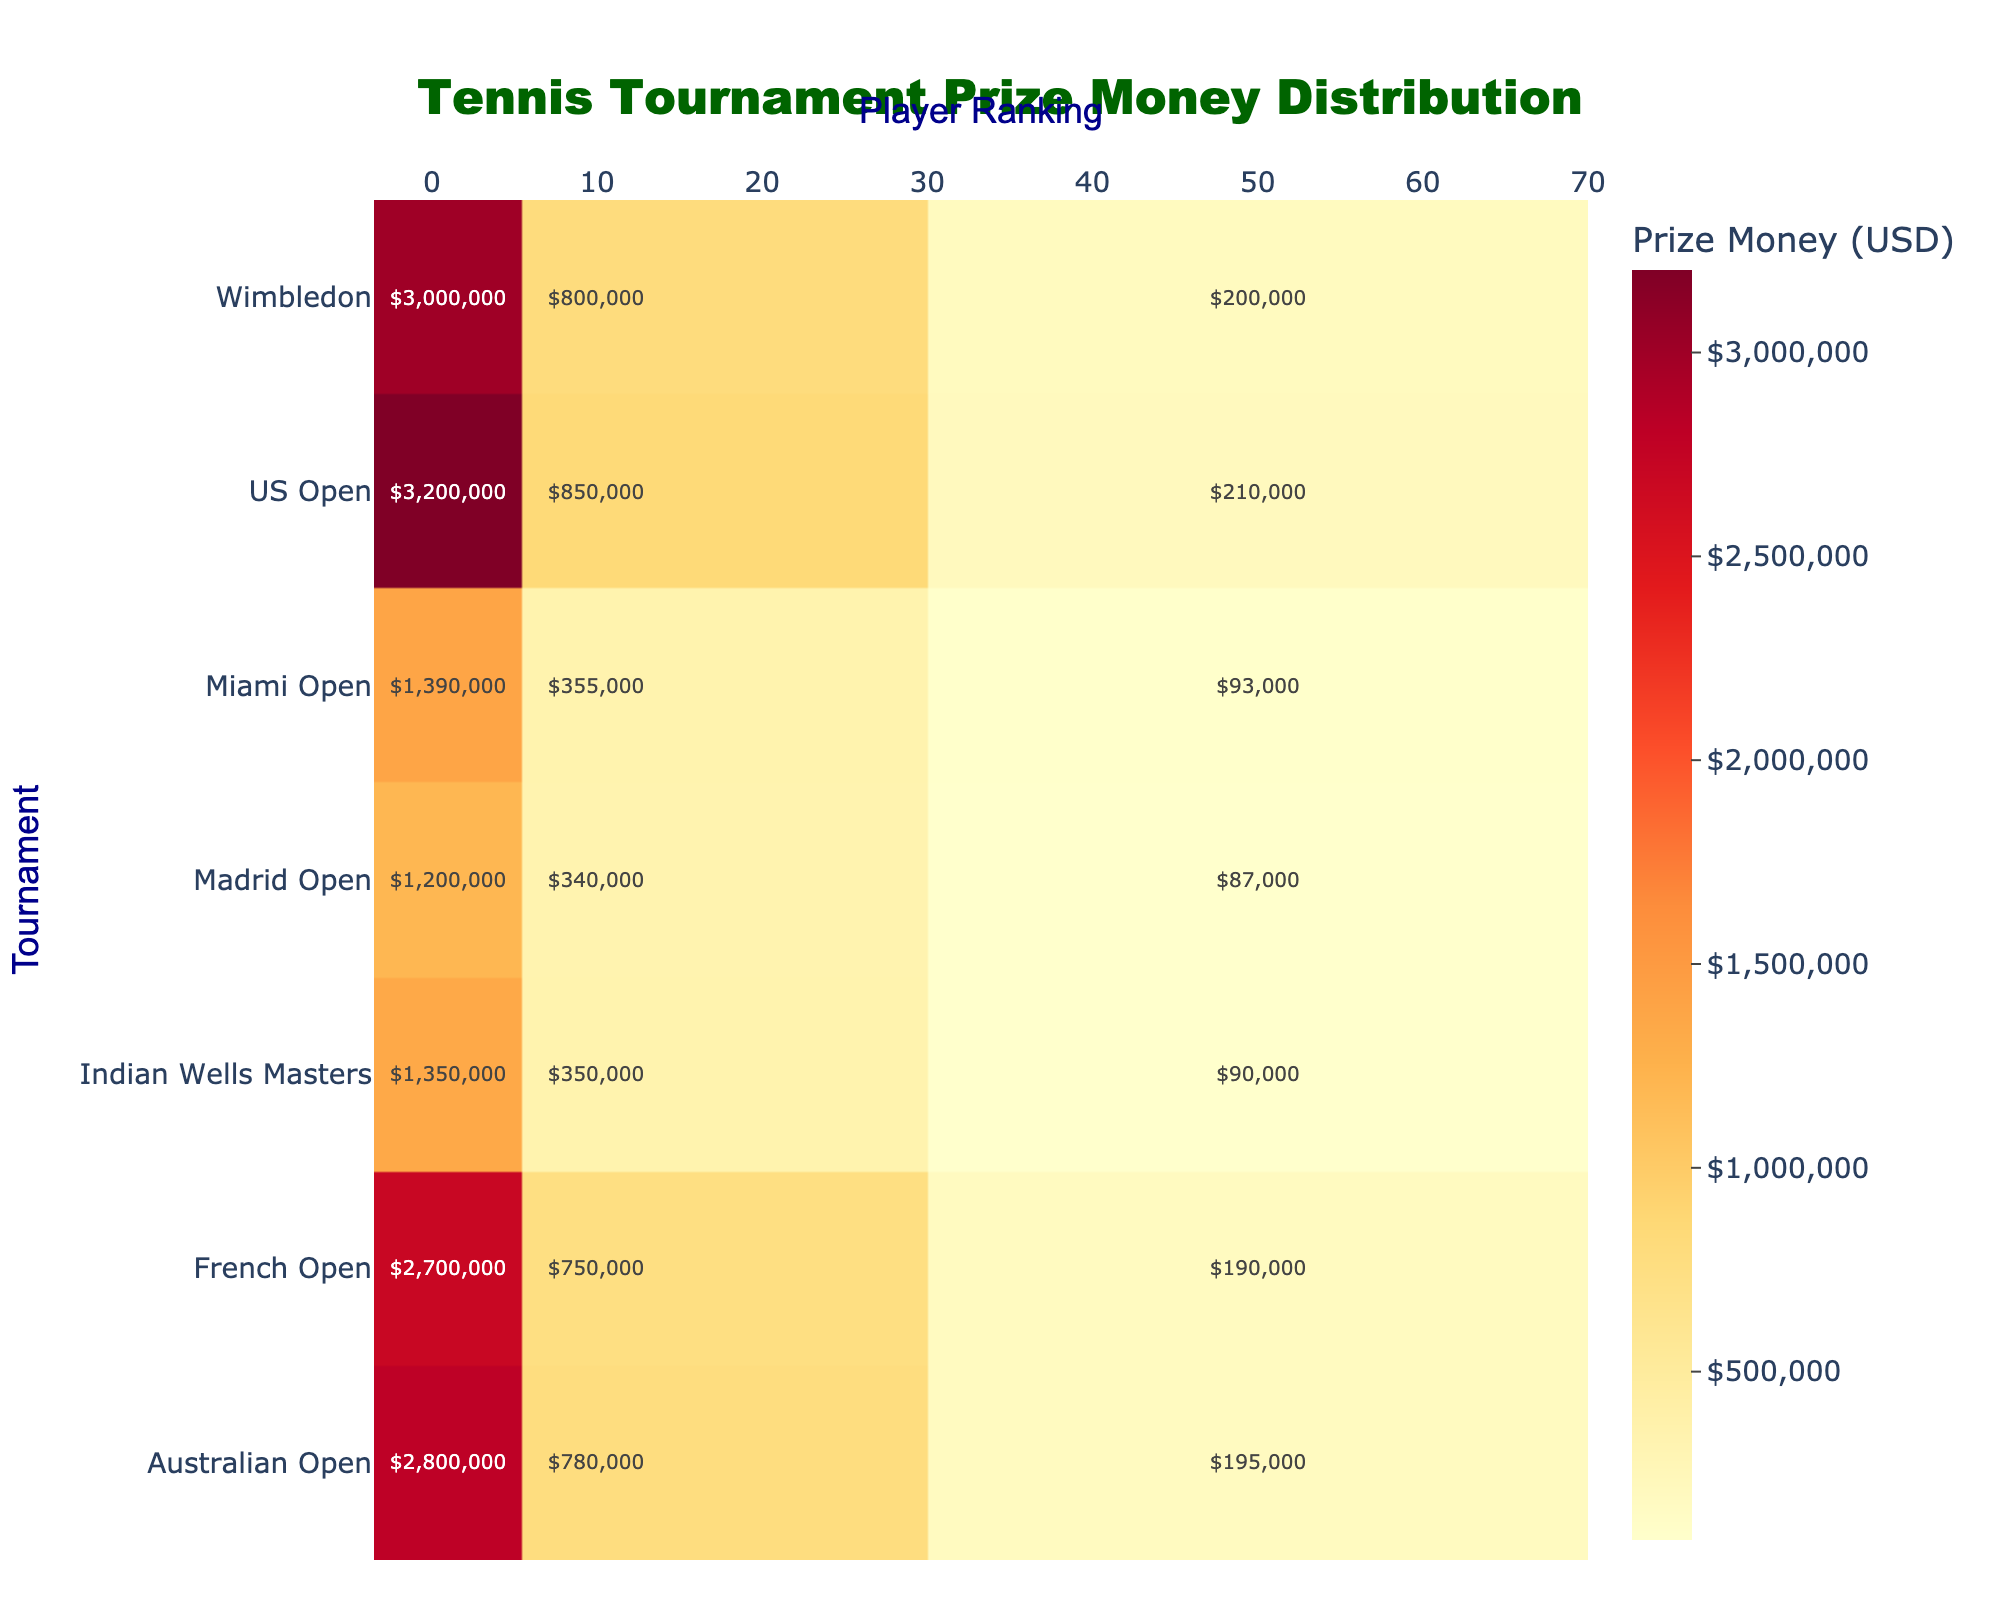What is the title of the heatmap? The title can be found at the top of the figure, usually centered. It provides a brief description of what the figure represents.
Answer: Tennis Tournament Prize Money Distribution Which tournament offers the highest prize money for the winner (rank 1)? Look for the cell with the highest value for the "Player Ranking" of 1 (top rank) across all tournaments in the heatmap. The largest prize amount in the '1' column indicates the tournament.
Answer: US Open What is the prize money for a 10th ranked player at Wimbledon? Find the row representing Wimbledon and locate the cell under the "10" column. The value in this cell represents the prize money for the 10th ranked player.
Answer: $800,000 Between the Australian Open and Indian Wells Masters, which tournament offers more prize money for the 50th ranked player? Compare the values in the column for Player Ranking 50 for both the Australian Open and Indian Wells Masters rows.
Answer: Australian Open ($195,000) What is the average prize money for the top-ranked players (rank 1) across all tournaments? Sum all the prize money values in the "1" column and divide by the number of tournaments.
Answer: (3000000 + 3200000 + 2700000 + 2800000 + 1350000 + 1390000 + 1200000) / 7 = $2,094,286 Which tournament offers the least prize money for players ranked 50? Identify the smallest value in the "50" column across all the rows representing different tournaments.
Answer: Madrid Open ($87,000) How much more prize money does a top-ranked player earn compared to a 50th ranked player at the French Open? Subtract the prize money of the 50th ranked player from that of the top-ranked player in the French Open row.
Answer: $2,700,000 - $190,000 = $2,510,000 Is there any tournament where a 10th ranked player earns more prize money than a top-ranked player at the Indian Wells Masters? Compare the values in the '10' column across all tournaments with the value in the '1' column for the Indian Wells Masters.
Answer: Yes (Wimbledon, US Open, French Open, Australian Open, Miami Open) Rank the tournaments in descending order based on the prize money offered to the top-ranked player (rank 1). Extract the values from the "1" column and order the tournaments from the highest to the lowest value.
Answer: US Open, Wimbledon, Australian Open, French Open, Miami Open, Indian Wells Masters, Madrid Open What is the total prize money offered to the 10th ranked players across all tournaments? Sum all the prize money values in the "10" column for all tournament rows.
Answer: $5,225,000 